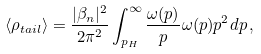<formula> <loc_0><loc_0><loc_500><loc_500>\langle \rho _ { t a i l } \rangle = \frac { | \beta _ { n } | ^ { 2 } } { 2 \pi ^ { 2 } } \int ^ { \infty } _ { p _ { H } } \frac { \omega ( p ) } { p } \omega ( p ) p ^ { 2 } d p \, ,</formula> 